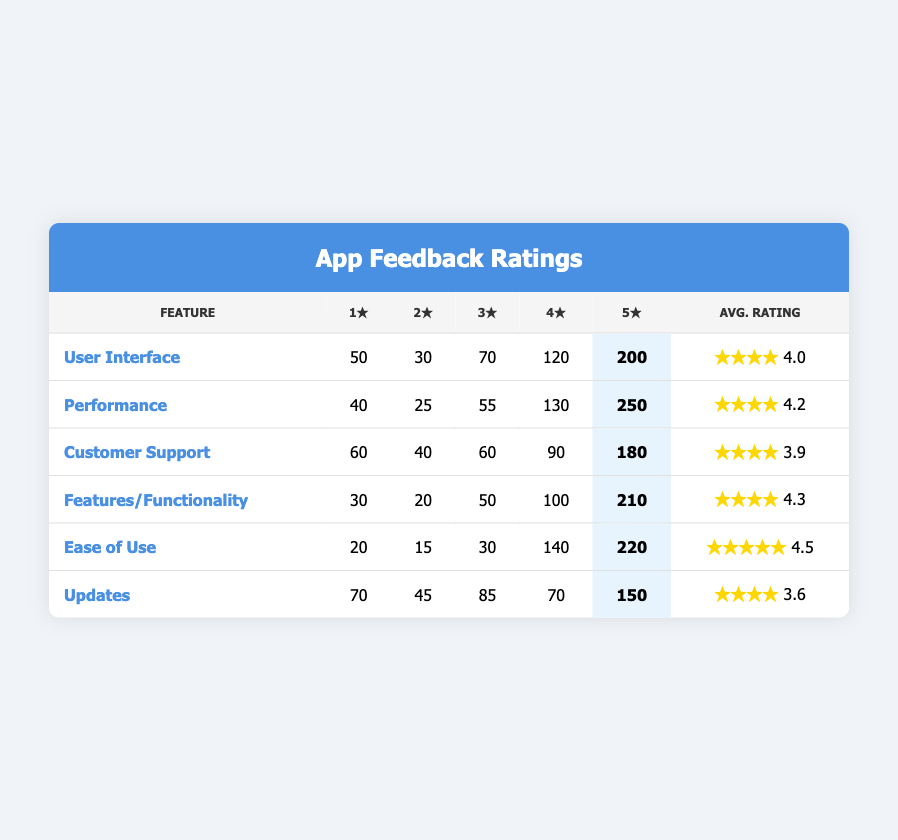What is the highest number of 5-star ratings in the table? By looking at the 5-star ratings column, the highest number is 250 for the Performance feature.
Answer: 250 Which app feature received the lowest average rating? The average ratings for the features are as follows: User Interface (4.0), Performance (4.2), Customer Support (3.9), Features/Functionality (4.3), Ease of Use (4.5), and Updates (3.6). The lowest average rating is 3.6 for Updates.
Answer: Updates How many total 1-star ratings were given across all features? Summing the 1-star ratings gives: 50 (UI) + 40 (Performance) + 60 (Customer Support) + 30 (Features) + 20 (Ease) + 70 (Updates) = 270.
Answer: 270 What is the difference between the highest and lowest number of 4-star ratings? The highest 4-star rating is 140 for Ease of Use and the lowest is 70 for Updates. The difference is 140 - 70 = 70.
Answer: 70 True or False: The Customer Support feature received more 3-star ratings than the Features/Functionality feature. Customer Support has 60 ratings for 3-stars, while Features/Functionality has 50. Since 60 > 50, the statement is True.
Answer: True How much higher is the average rating of Ease of Use compared to Customer Support? The average rating for Ease of Use is 4.5, and for Customer Support, it is 3.9. The difference is 4.5 - 3.9 = 0.6.
Answer: 0.6 Which feature has the second highest number of 4-star ratings? The number of 4-star ratings are: UI (120), Performance (130), Customer Support (90), Features/Functionality (100), Ease of Use (140), and Updates (70). The second highest is 120 for User Interface.
Answer: User Interface What is the percentage of 5-star ratings for the Ease of Use feature? The number of 5-star ratings is 220. The total sum of ratings for Ease of Use is 20 (1-star) + 15 (2-star) + 30 (3-star) + 140 (4-star) + 220 (5-star) = 415. Thus, the percentage = (220/415) * 100 = approximately 53.37%.
Answer: 53.37% Which two features combined have more than 400 total ratings? The total ratings for each feature are: UI (50 + 30 + 70 + 120 + 200 = 470), Performance (40 + 25 + 55 + 130 + 250 = 500), Customer Support (60 + 40 + 60 + 90 + 180 = 430), Features (30 + 20 + 50 + 100 + 210 = 410), Ease of Use (20 + 15 + 30 + 140 + 220 = 415), Updates (70 + 45 + 85 + 70 + 150 = 420). UI and Performance combine for 470 + 500 = 970, which is more than 400.
Answer: UI and Performance How many more ratings did the Performance feature receive compared to the Customer Support feature overall? The total ratings for Performance are 500, and for Customer Support, it is 430. Thus, Performance received 500 - 430 = 70 more ratings.
Answer: 70 